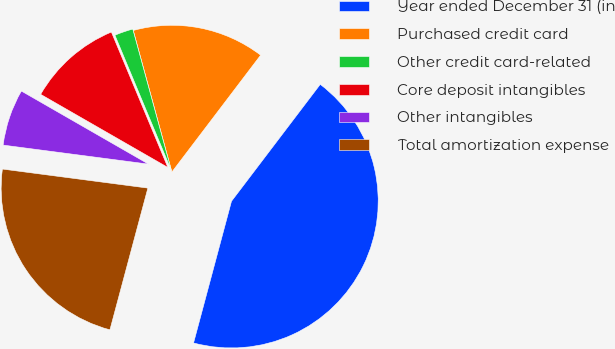<chart> <loc_0><loc_0><loc_500><loc_500><pie_chart><fcel>Year ended December 31 (in<fcel>Purchased credit card<fcel>Other credit card-related<fcel>Core deposit intangibles<fcel>Other intangibles<fcel>Total amortization expense<nl><fcel>43.83%<fcel>14.58%<fcel>2.05%<fcel>10.41%<fcel>6.23%<fcel>22.91%<nl></chart> 